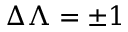<formula> <loc_0><loc_0><loc_500><loc_500>\Delta \Lambda = \pm 1</formula> 